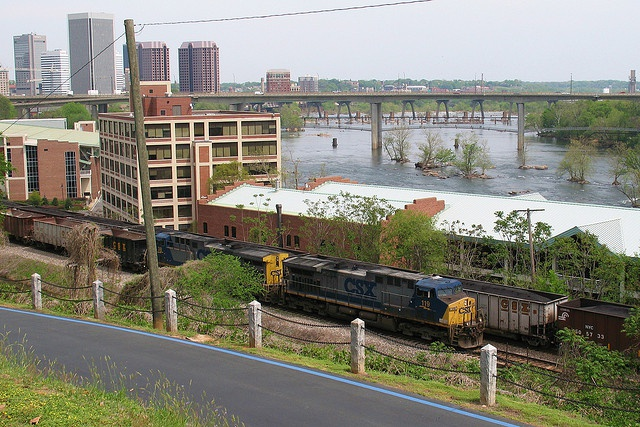Describe the objects in this image and their specific colors. I can see train in lightgray, black, gray, and maroon tones, train in lightgray, black, gray, and maroon tones, and car in lightgray, gray, brown, and salmon tones in this image. 